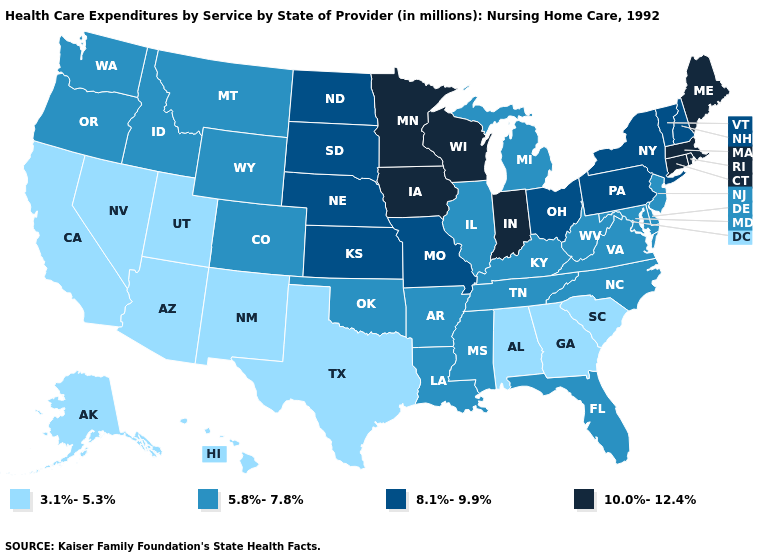Does Minnesota have a higher value than Oklahoma?
Short answer required. Yes. Among the states that border New Jersey , which have the lowest value?
Concise answer only. Delaware. Which states hav the highest value in the MidWest?
Concise answer only. Indiana, Iowa, Minnesota, Wisconsin. What is the value of New Jersey?
Answer briefly. 5.8%-7.8%. What is the value of Rhode Island?
Keep it brief. 10.0%-12.4%. What is the value of Pennsylvania?
Quick response, please. 8.1%-9.9%. What is the value of Massachusetts?
Quick response, please. 10.0%-12.4%. What is the value of Rhode Island?
Keep it brief. 10.0%-12.4%. Does the first symbol in the legend represent the smallest category?
Answer briefly. Yes. Does New Jersey have the lowest value in the USA?
Keep it brief. No. What is the lowest value in the West?
Keep it brief. 3.1%-5.3%. What is the value of Washington?
Give a very brief answer. 5.8%-7.8%. What is the lowest value in the MidWest?
Give a very brief answer. 5.8%-7.8%. Among the states that border California , does Oregon have the lowest value?
Quick response, please. No. What is the value of Michigan?
Keep it brief. 5.8%-7.8%. 